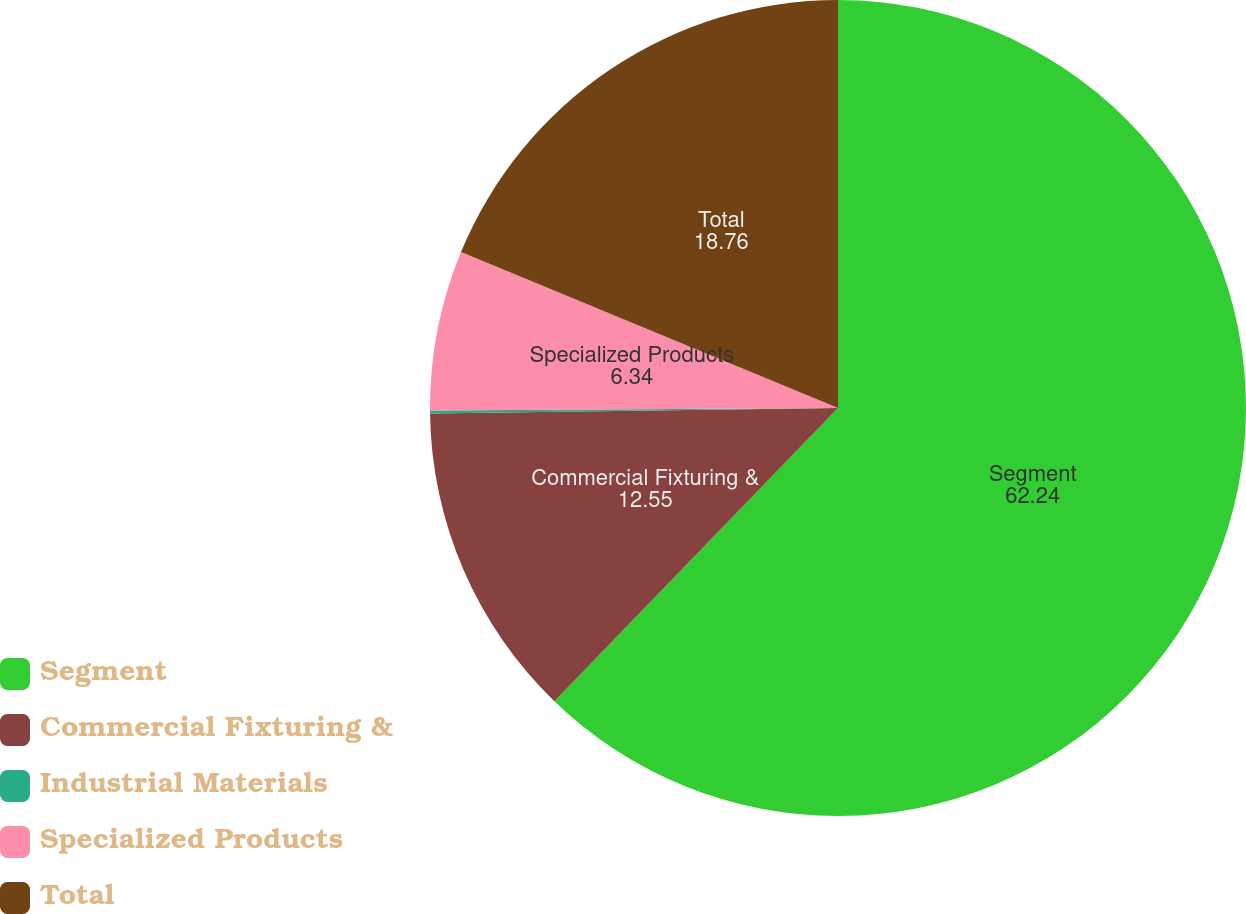<chart> <loc_0><loc_0><loc_500><loc_500><pie_chart><fcel>Segment<fcel>Commercial Fixturing &<fcel>Industrial Materials<fcel>Specialized Products<fcel>Total<nl><fcel>62.24%<fcel>12.55%<fcel>0.12%<fcel>6.34%<fcel>18.76%<nl></chart> 